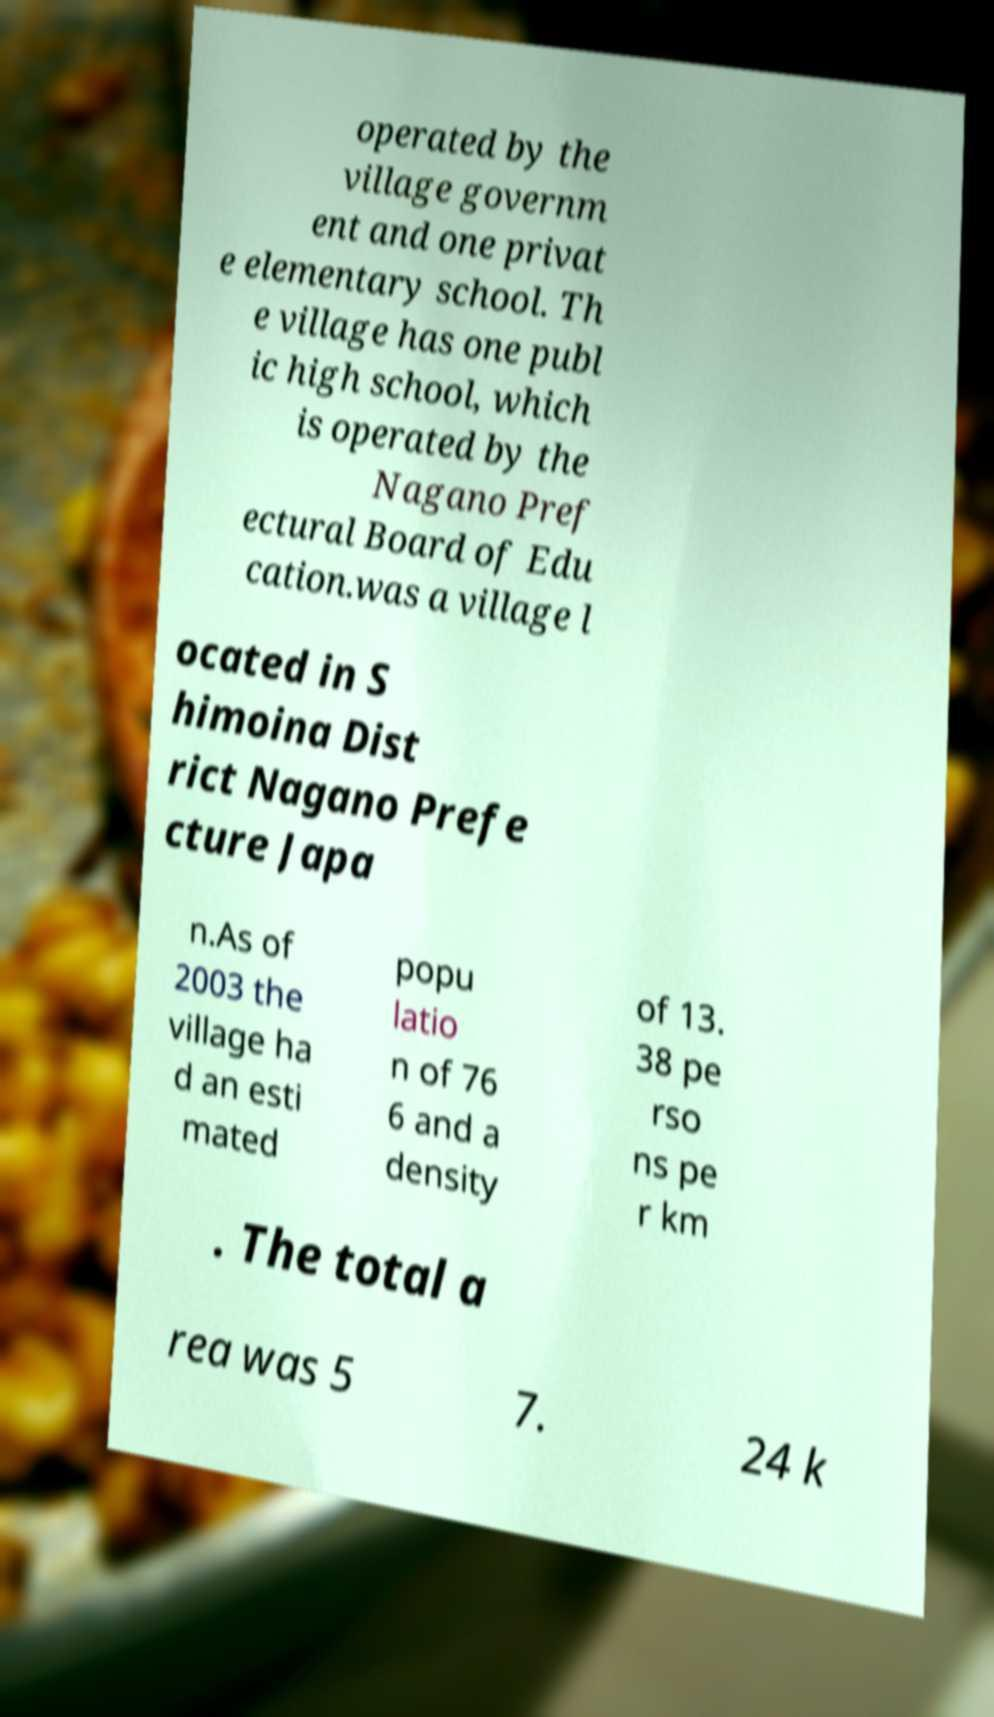Please identify and transcribe the text found in this image. operated by the village governm ent and one privat e elementary school. Th e village has one publ ic high school, which is operated by the Nagano Pref ectural Board of Edu cation.was a village l ocated in S himoina Dist rict Nagano Prefe cture Japa n.As of 2003 the village ha d an esti mated popu latio n of 76 6 and a density of 13. 38 pe rso ns pe r km . The total a rea was 5 7. 24 k 